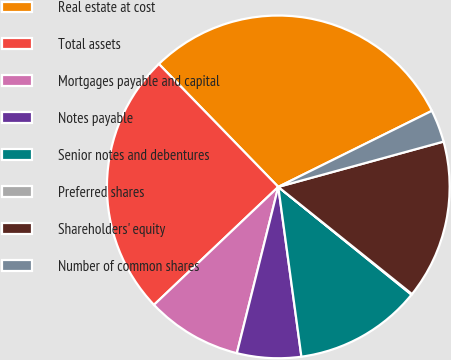Convert chart to OTSL. <chart><loc_0><loc_0><loc_500><loc_500><pie_chart><fcel>Real estate at cost<fcel>Total assets<fcel>Mortgages payable and capital<fcel>Notes payable<fcel>Senior notes and debentures<fcel>Preferred shares<fcel>Shareholders' equity<fcel>Number of common shares<nl><fcel>29.95%<fcel>24.81%<fcel>9.03%<fcel>6.04%<fcel>12.02%<fcel>0.07%<fcel>15.01%<fcel>3.06%<nl></chart> 